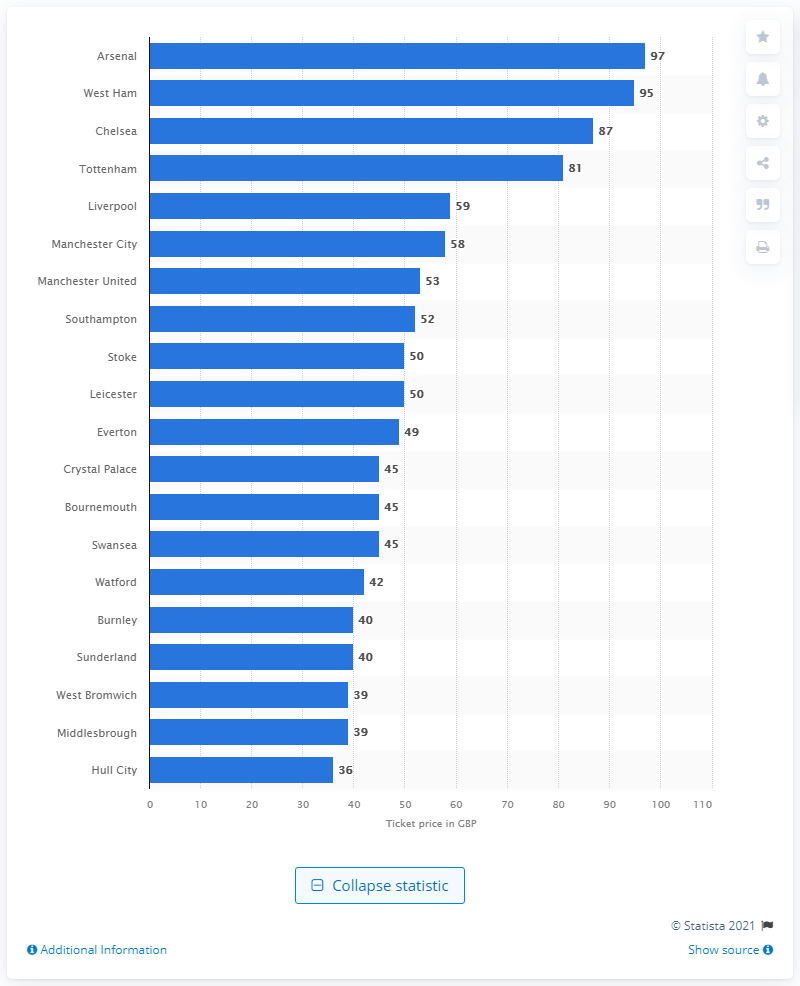Mention a couple of crucial points in this snapshot. Arsenal sold the most expensive match-day ticket during the 2019/2020 Premier League season for 97 pounds. During the 2019/2020 Premier League season, Arsenal sold the most expensive match-day ticket for £97. 